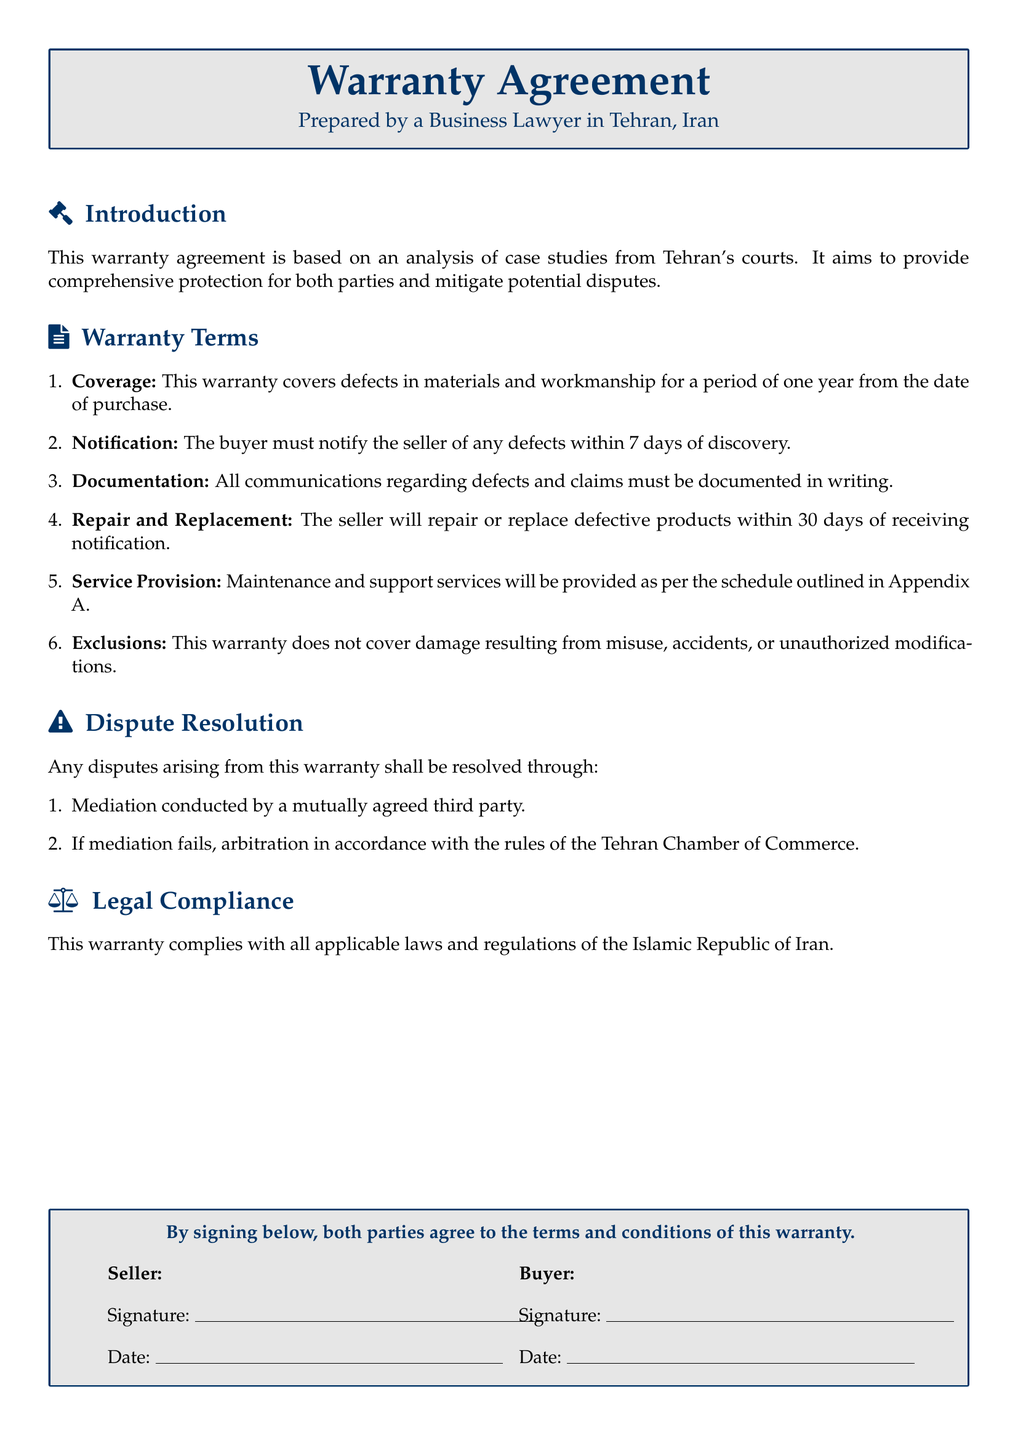What is the duration of the warranty coverage? The warranty covers defects in materials and workmanship for a period of one year from the date of purchase.
Answer: One year What should the buyer do upon discovering a defect? The buyer must notify the seller of any defects within 7 days of discovery.
Answer: Notify the seller How long does the seller have to repair or replace defective products? The seller will repair or replace defective products within 30 days of receiving notification.
Answer: 30 days What services are included in the warranty? Maintenance and support services will be provided as per the schedule outlined in Appendix A.
Answer: Maintenance and support services What types of damage are excluded from the warranty? This warranty does not cover damage resulting from misuse, accidents, or unauthorized modifications.
Answer: Misuse, accidents, unauthorized modifications What is the first step for dispute resolution? Any disputes arising from this warranty shall be resolved through mediation conducted by a mutually agreed third party.
Answer: Mediation What organization governs arbitration for disputes? Arbitration is conducted in accordance with the rules of the Tehran Chamber of Commerce.
Answer: Tehran Chamber of Commerce Which country's laws does the warranty comply with? This warranty complies with all applicable laws and regulations of the Islamic Republic of Iran.
Answer: Islamic Republic of Iran Who prepared the warranty agreement? The warranty agreement is prepared by a Business Lawyer in Tehran, Iran.
Answer: Business Lawyer in Tehran 